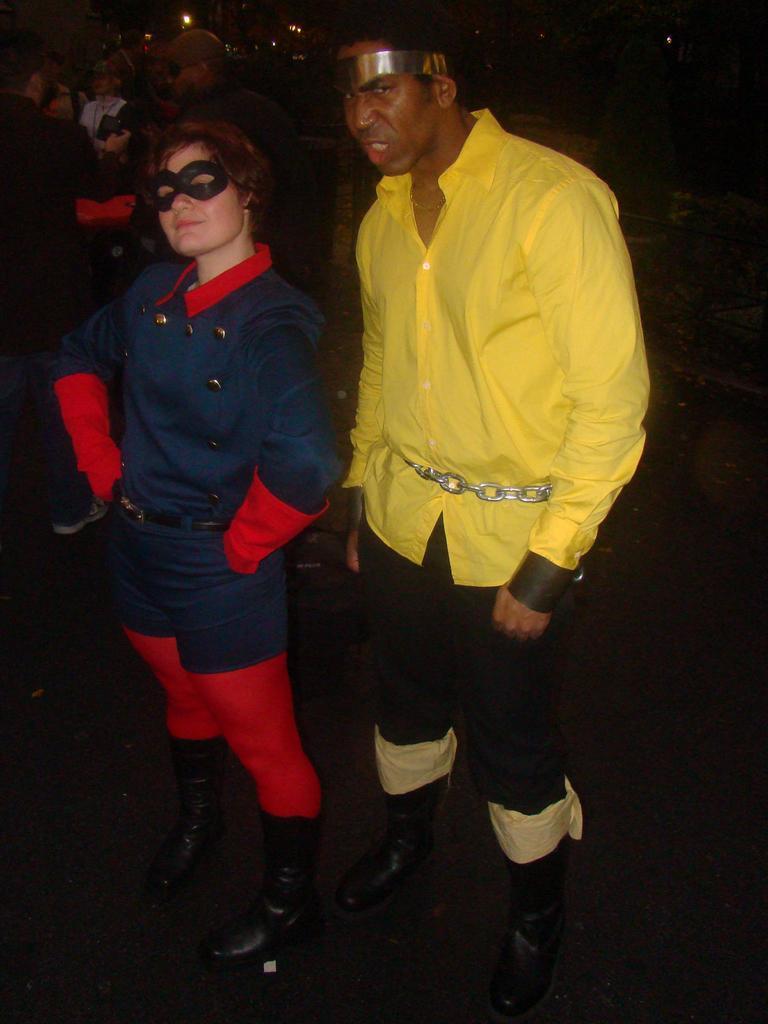Can you describe this image briefly? This picture is clicked inside. In the foreground there is a man wearing yellow color shirt and standing on the ground and there is a person wearing a blue color dress and standing on the ground. In the background we can see the lights, group of persons and some other objects. 